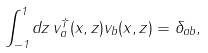<formula> <loc_0><loc_0><loc_500><loc_500>\int _ { - 1 } ^ { 1 } d z \, v _ { a } ^ { \dagger } ( x , z ) v _ { b } ( x , z ) = \delta _ { a b } ,</formula> 